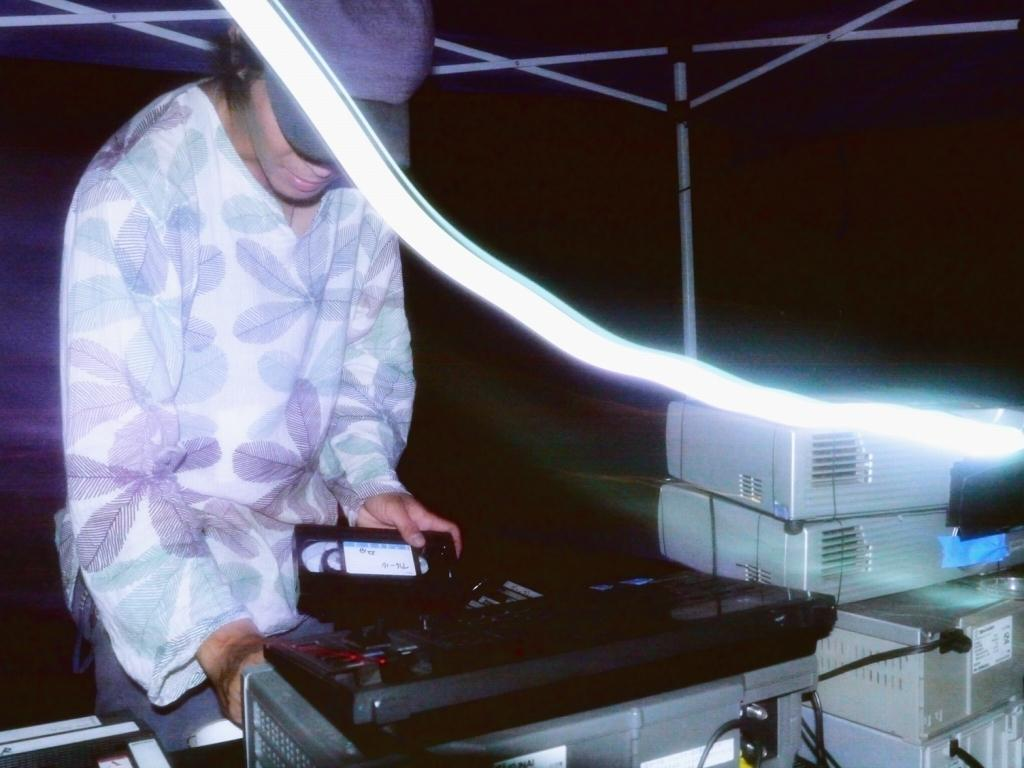Who is present in the image? There is a person in the image. What is the person wearing on their head? The person is wearing a cap. Where is the person standing in relation to the table? The person is standing in front of a table. What types of items are on the table? There are electronic devices and machines on the table. How comfortable is the sink in the image? There is no sink present in the image, so it is not possible to determine its comfort level. 